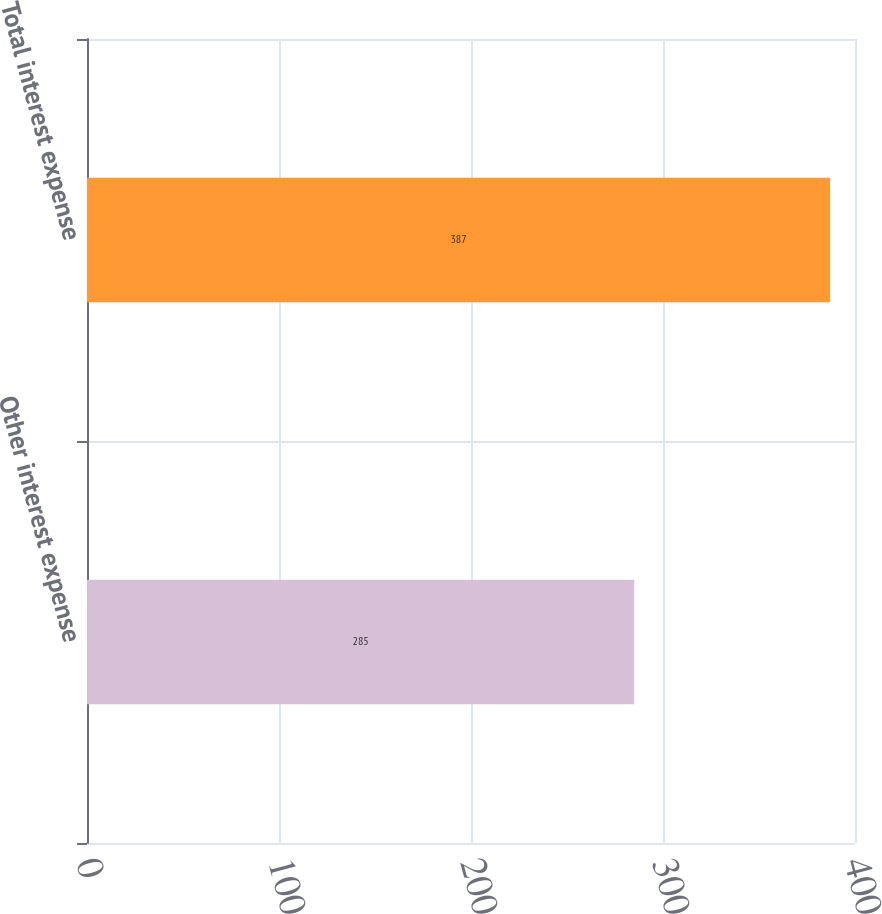<chart> <loc_0><loc_0><loc_500><loc_500><bar_chart><fcel>Other interest expense<fcel>Total interest expense<nl><fcel>285<fcel>387<nl></chart> 